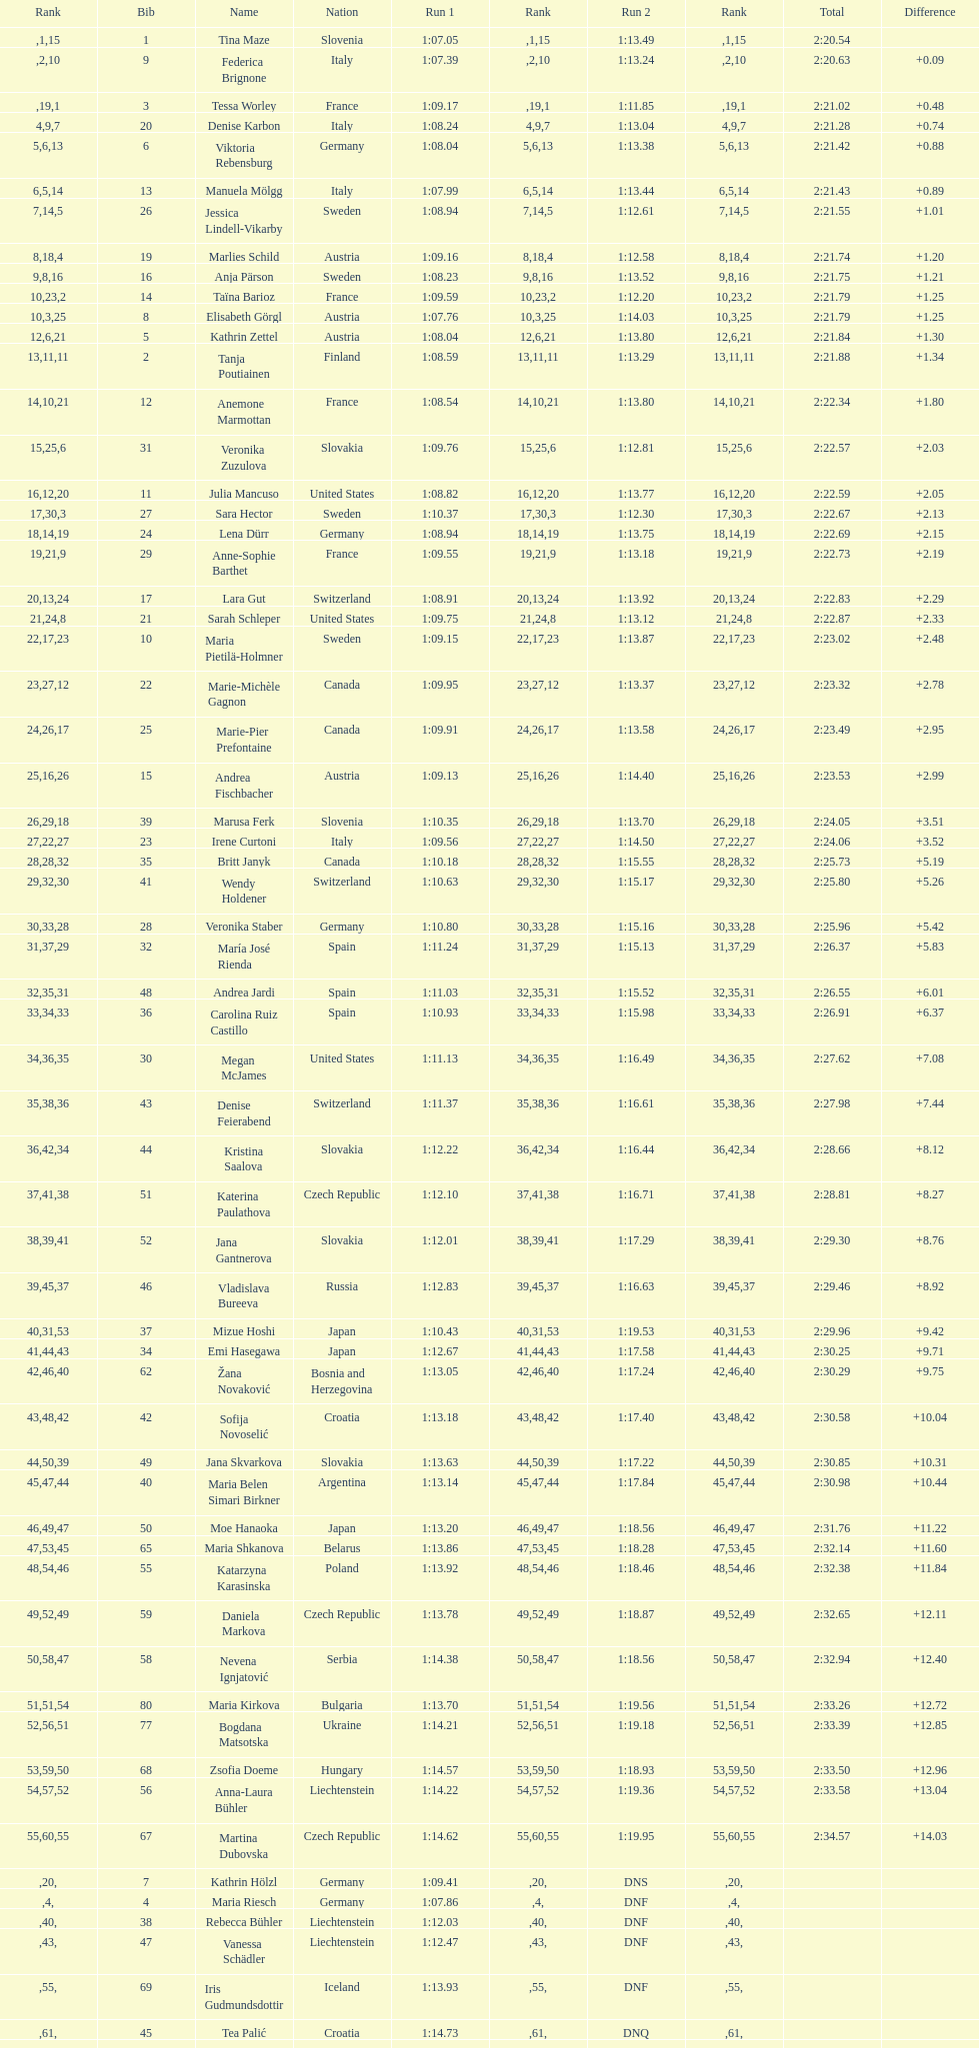How many italians completed in the top ten? 3. 